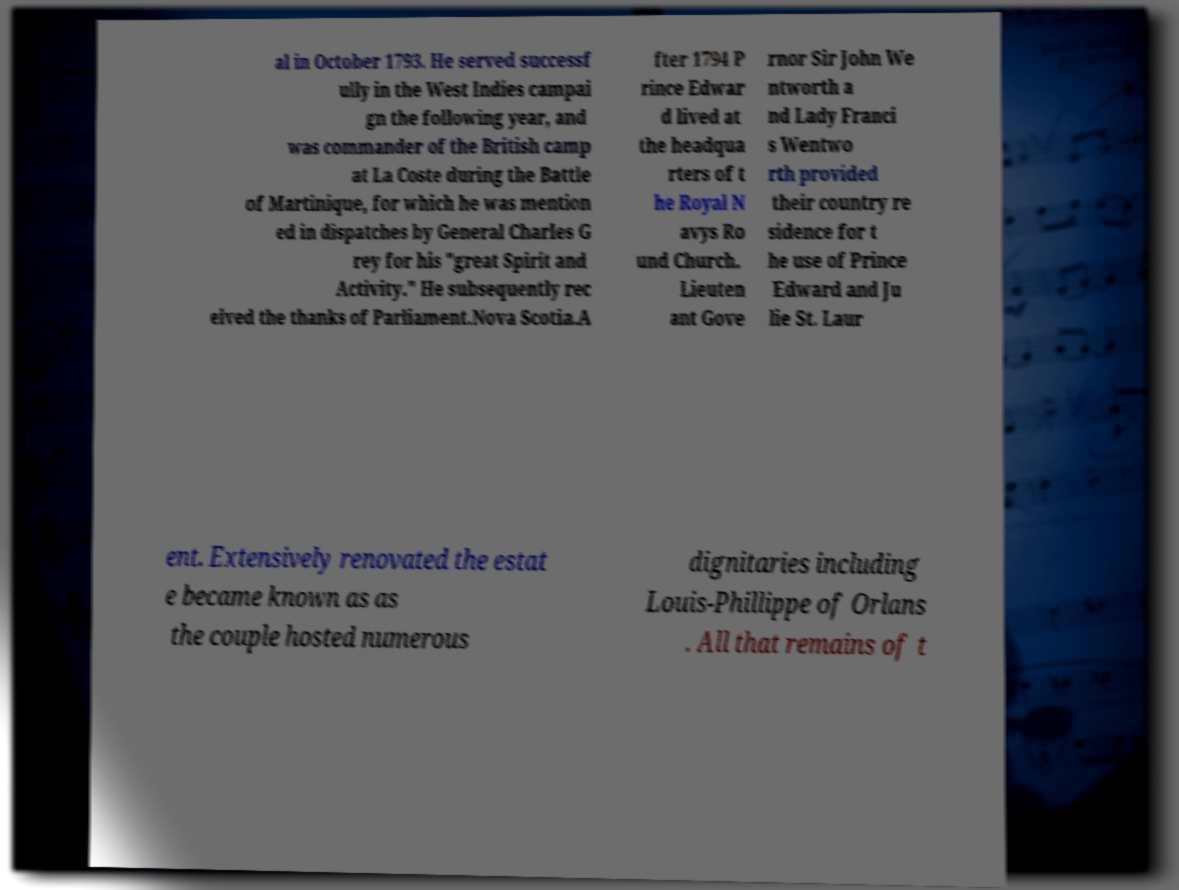Can you accurately transcribe the text from the provided image for me? al in October 1793. He served successf ully in the West Indies campai gn the following year, and was commander of the British camp at La Coste during the Battle of Martinique, for which he was mention ed in dispatches by General Charles G rey for his "great Spirit and Activity." He subsequently rec eived the thanks of Parliament.Nova Scotia.A fter 1794 P rince Edwar d lived at the headqua rters of t he Royal N avys Ro und Church. Lieuten ant Gove rnor Sir John We ntworth a nd Lady Franci s Wentwo rth provided their country re sidence for t he use of Prince Edward and Ju lie St. Laur ent. Extensively renovated the estat e became known as as the couple hosted numerous dignitaries including Louis-Phillippe of Orlans . All that remains of t 